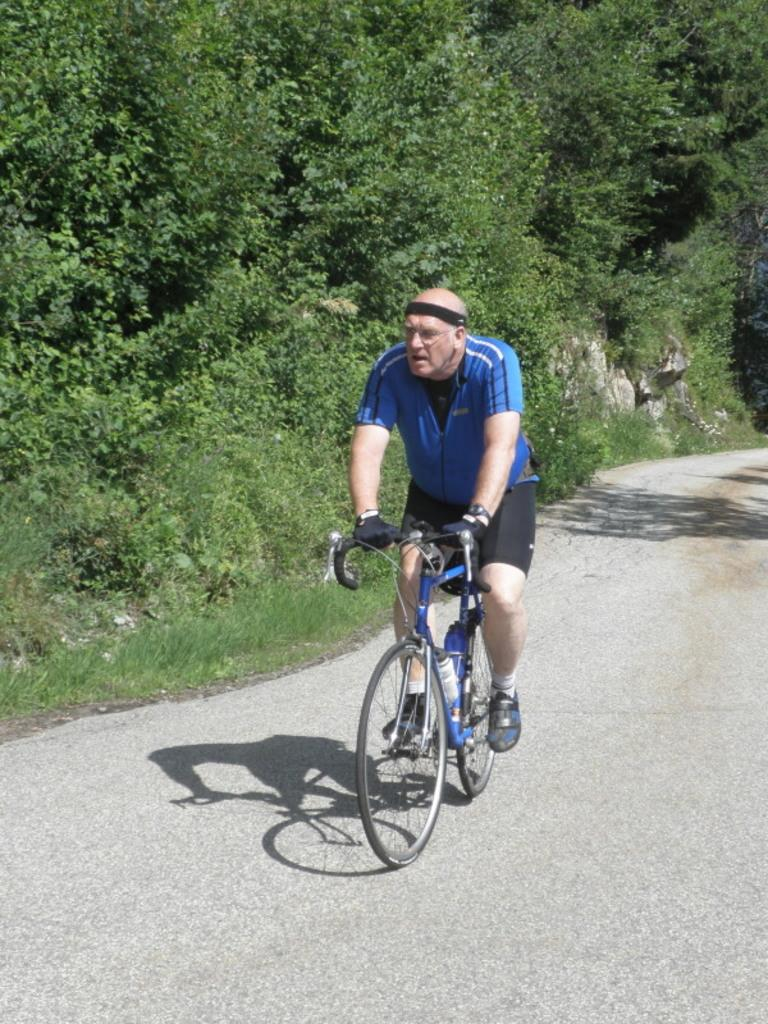What is the person in the image doing? The person is sitting and riding a bicycle. Where is the bicycle located? The bicycle is on the road. What can be seen in the background of the image? There are trees, stones, and grass in the background of the image. What type of rice can be seen growing in the background of the image? There is no rice visible in the image; the background features trees, stones, and grass. 